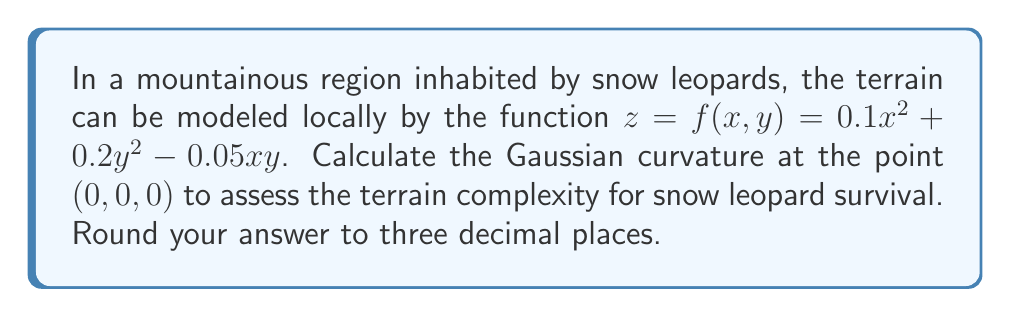Show me your answer to this math problem. To compute the Gaussian curvature, we'll follow these steps:

1) The Gaussian curvature K is given by:
   $$K = \frac{f_{xx}f_{yy} - f_{xy}^2}{(1 + f_x^2 + f_y^2)^2}$$

2) Calculate the partial derivatives:
   $f_x = 0.2x - 0.05y$
   $f_y = 0.4y - 0.05x$
   $f_{xx} = 0.2$
   $f_{yy} = 0.4$
   $f_{xy} = -0.05$

3) Evaluate these at the point (0,0,0):
   $f_x(0,0) = 0$
   $f_y(0,0) = 0$
   $f_{xx}(0,0) = 0.2$
   $f_{yy}(0,0) = 0.4$
   $f_{xy}(0,0) = -0.05$

4) Substitute into the Gaussian curvature formula:
   $$K = \frac{(0.2)(0.4) - (-0.05)^2}{(1 + 0^2 + 0^2)^2}$$

5) Simplify:
   $$K = \frac{0.08 - 0.0025}{1} = 0.0775$$

6) Round to three decimal places:
   $K \approx 0.078$

The positive Gaussian curvature indicates that the terrain at this point is dome-shaped, which could provide vantage points for snow leopards to survey their territory.
Answer: 0.078 